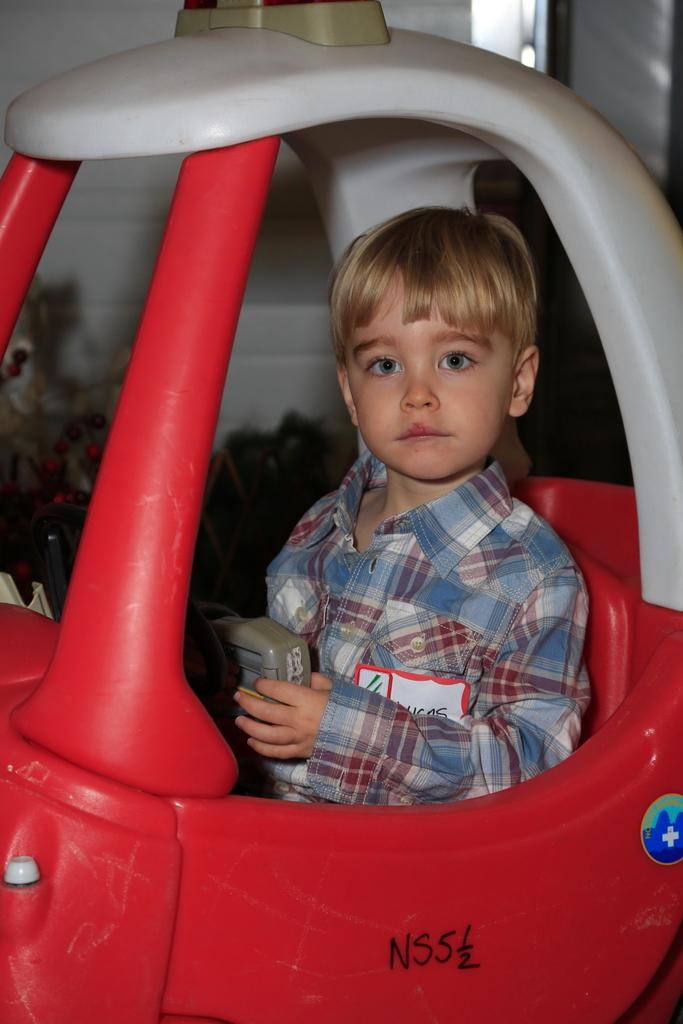What is the main subject of the image? The main subject of the image is a kid. What is the kid doing in the image? The kid is holding an object and sitting in a toy car. What can be seen in the background of the image? There is a wall in the background of the image. How many fish are swimming in the toy car with the kid? There are no fish present in the image; the kid is sitting in a toy car. What type of cart is connected to the wall in the background? There is no cart connected to the wall in the background of the image. 